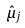<formula> <loc_0><loc_0><loc_500><loc_500>\hat { \mu } _ { j }</formula> 